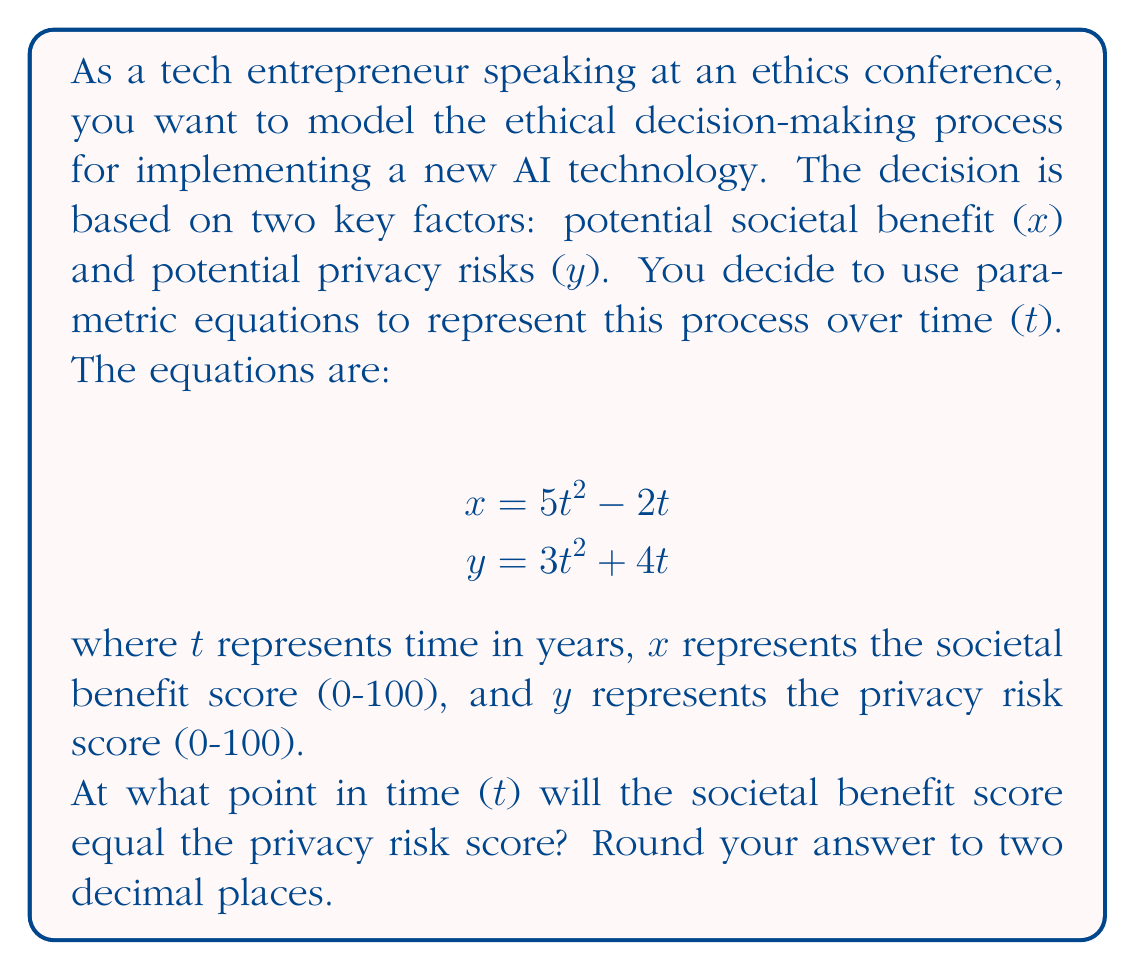Show me your answer to this math problem. To solve this problem, we need to find the point where the x and y values are equal. This means we need to set the two parametric equations equal to each other and solve for t:

1) Set the equations equal:
   $$5t^2 - 2t = 3t^2 + 4t$$

2) Subtract $3t^2$ from both sides:
   $$2t^2 - 2t = 4t$$

3) Subtract 4t from both sides:
   $$2t^2 - 6t = 0$$

4) Factor out the common factor:
   $$2t(t - 3) = 0$$

5) Set each factor to zero and solve:
   $$2t = 0$$ or $$t - 3 = 0$$
   $$t = 0$$ or $$t = 3$$

6) Since t represents time, we can discard the negative solution. The valid solution is t = 3.

To verify, we can plug t = 3 back into both original equations:

For x: $$5(3)^2 - 2(3) = 45 - 6 = 39$$
For y: $$3(3)^2 + 4(3) = 27 + 12 = 39$$

Indeed, at t = 3, both x and y equal 39, confirming our solution.
Answer: The societal benefit score will equal the privacy risk score at t = 3.00 years. 